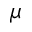<formula> <loc_0><loc_0><loc_500><loc_500>\mu</formula> 